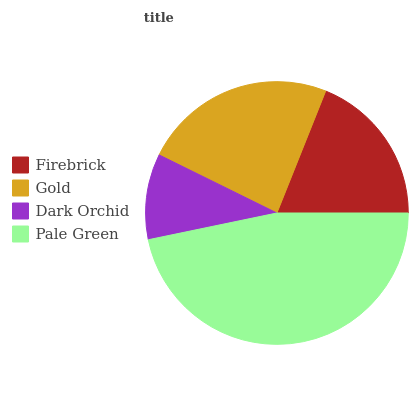Is Dark Orchid the minimum?
Answer yes or no. Yes. Is Pale Green the maximum?
Answer yes or no. Yes. Is Gold the minimum?
Answer yes or no. No. Is Gold the maximum?
Answer yes or no. No. Is Gold greater than Firebrick?
Answer yes or no. Yes. Is Firebrick less than Gold?
Answer yes or no. Yes. Is Firebrick greater than Gold?
Answer yes or no. No. Is Gold less than Firebrick?
Answer yes or no. No. Is Gold the high median?
Answer yes or no. Yes. Is Firebrick the low median?
Answer yes or no. Yes. Is Firebrick the high median?
Answer yes or no. No. Is Dark Orchid the low median?
Answer yes or no. No. 